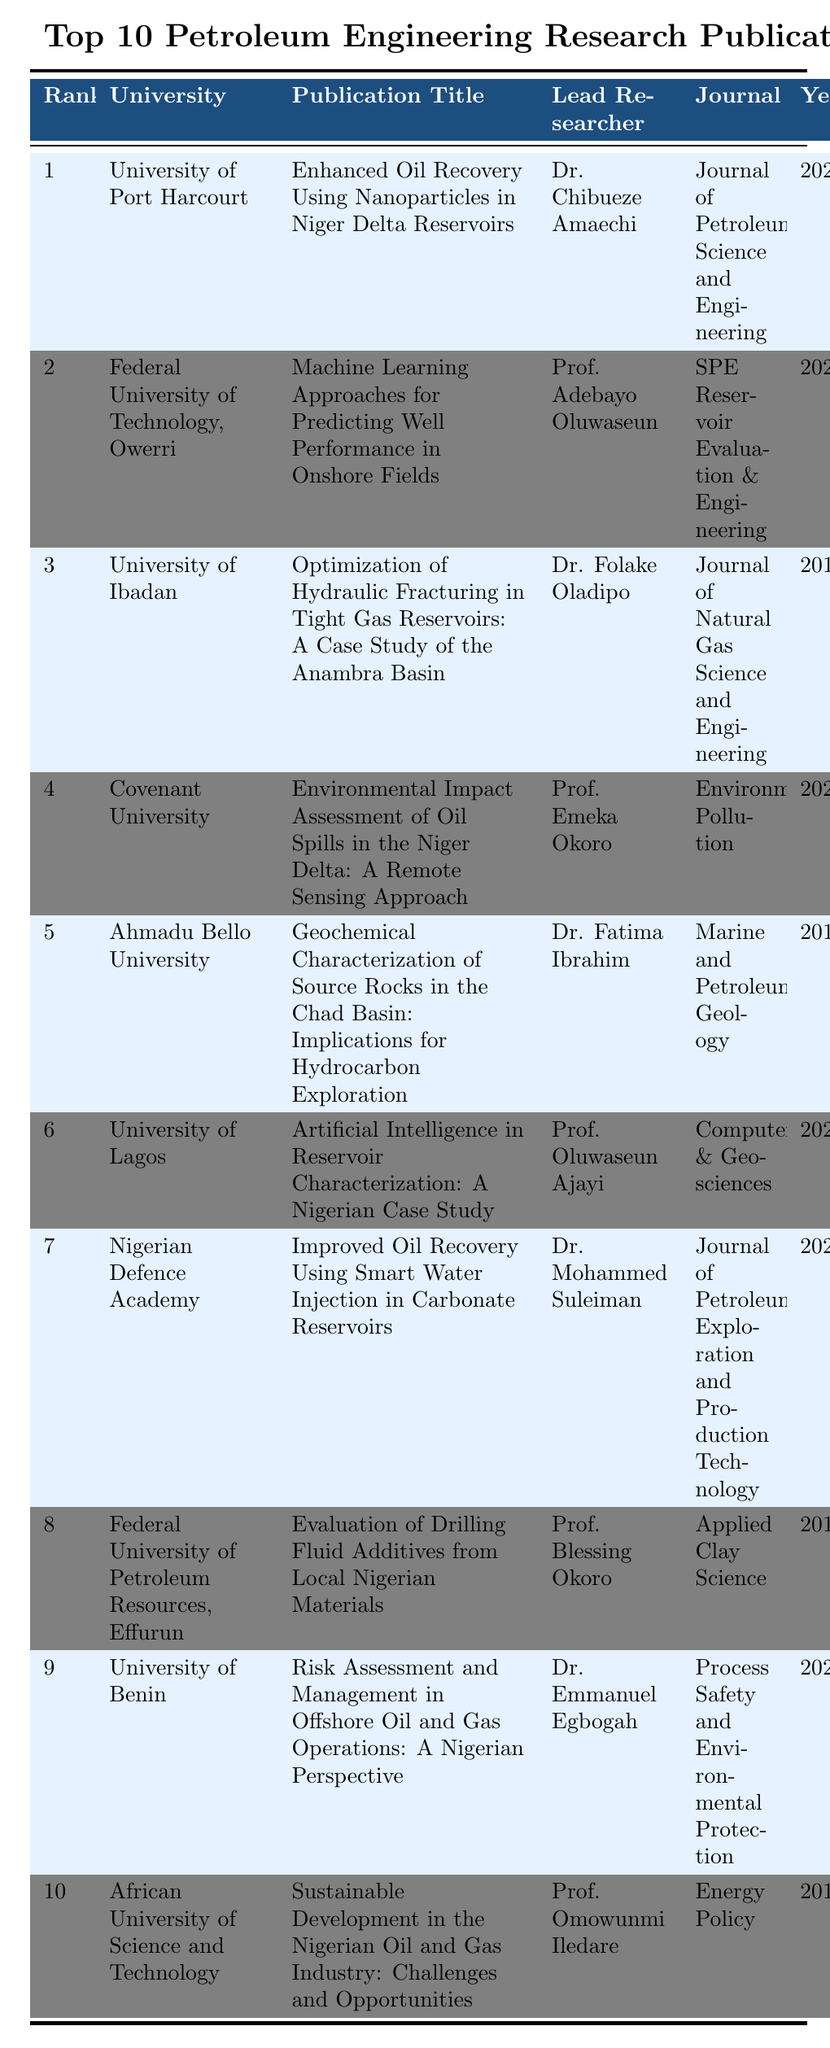What is the title of the publication from the University of Port Harcourt? The table lists the publication title for each university. Looking for the entry for the University of Port Harcourt, the title is "Enhanced Oil Recovery Using Nanoparticles in Niger Delta Reservoirs."
Answer: Enhanced Oil Recovery Using Nanoparticles in Niger Delta Reservoirs Which publication has the highest number of citations? By reviewing the "Citations" column in the table, the publication from the University of Port Harcourt has the highest citations, with a total of 178.
Answer: University of Port Harcourt How many publications received more than 100 citations? By counting the entries in the "Citations" column, the publications with citations above 100 are: University of Port Harcourt (178), Federal University of Technology, Owerri (156), University of Ibadan (143), Covenant University (132), Ahmadu Bello University (129), University of Lagos (118), and Nigerian Defence Academy (105). This totals to 7 publications.
Answer: 7 What is the average number of citations for all the publications? Summing the citations: 178 + 156 + 143 + 132 + 129 + 118 + 105 + 97 + 86 + 82 = 1,005. There are 10 publications, so the average is 1,005 / 10 = 100.5.
Answer: 100.5 Which researcher led the publication with the most citations, and what is the year of that publication? The publication with 178 citations is led by Dr. Chibueze Amaechi, and it was published in 2021.
Answer: Dr. Chibueze Amaechi, 2021 Is there any publication from the year 2018 that has more than 80 citations? Indeed, the publication from Ahmadu Bello University in 2018 has 129 citations, confirming that there is a publication from that year with citations over 80.
Answer: Yes How many universities have publications from the year 2022? Checking the "Year" column, Covenant University and University of Benin both have publications from 2022. That accounts for 2 universities.
Answer: 2 What is the range of citations from the publications listed? The highest citations is 178 (University of Port Harcourt) and the lowest is 82 (African University of Science and Technology). The range is calculated as 178 - 82 = 96.
Answer: 96 Which journal had the third-most cited publication? The third-most cited publication, which belongs to the University of Ibadan, is published in the "Journal of Natural Gas Science and Engineering" with 143 citations.
Answer: Journal of Natural Gas Science and Engineering List the universities that published in the year 2020. Review the "Year" column for 2020, which shows the following universities: Federal University of Technology, Owerri, and Nigerian Defence Academy.
Answer: Federal University of Technology, Owerri; Nigerian Defence Academy 